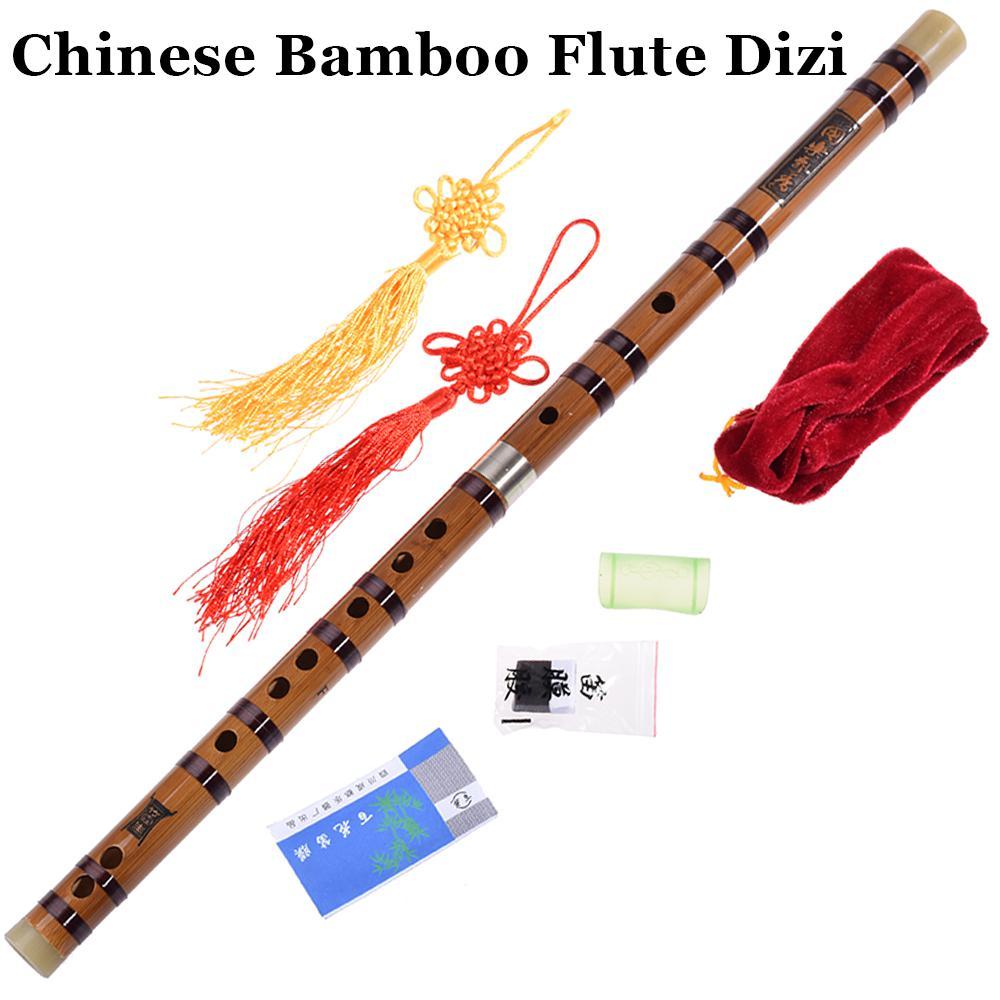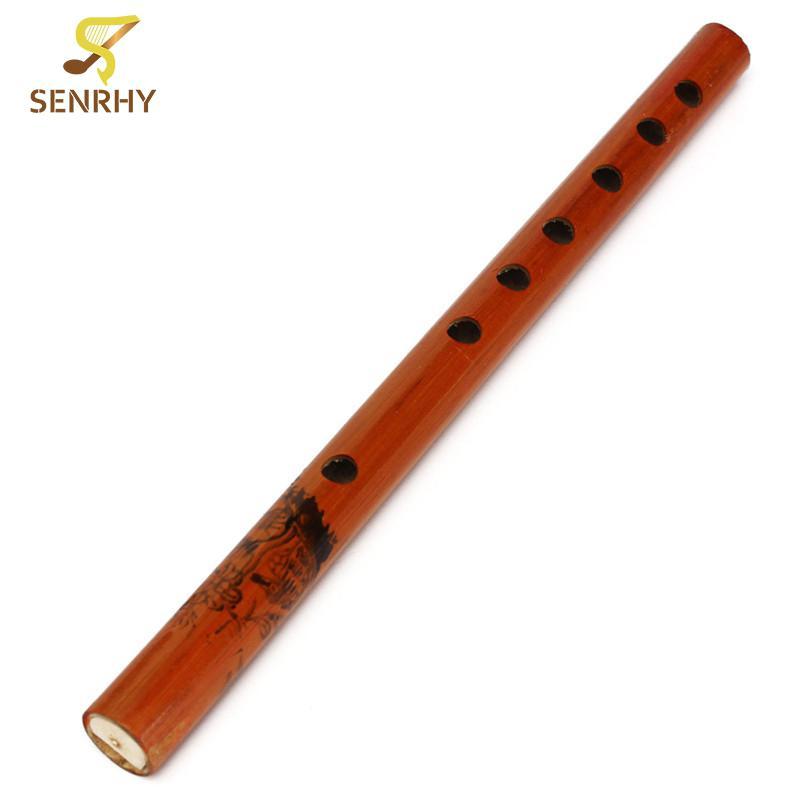The first image is the image on the left, the second image is the image on the right. Considering the images on both sides, is "There are exactly two flutes." valid? Answer yes or no. Yes. The first image is the image on the left, the second image is the image on the right. Analyze the images presented: Is the assertion "Each image features one bamboo flute displayed diagonally so one end is on the upper right." valid? Answer yes or no. Yes. 